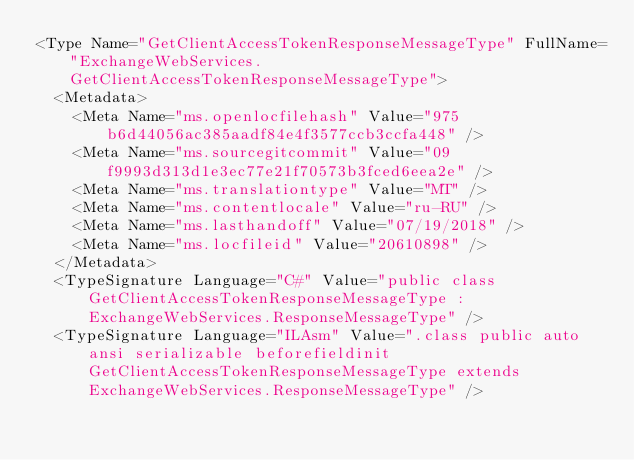<code> <loc_0><loc_0><loc_500><loc_500><_XML_><Type Name="GetClientAccessTokenResponseMessageType" FullName="ExchangeWebServices.GetClientAccessTokenResponseMessageType">
  <Metadata>
    <Meta Name="ms.openlocfilehash" Value="975b6d44056ac385aadf84e4f3577ccb3ccfa448" />
    <Meta Name="ms.sourcegitcommit" Value="09f9993d313d1e3ec77e21f70573b3fced6eea2e" />
    <Meta Name="ms.translationtype" Value="MT" />
    <Meta Name="ms.contentlocale" Value="ru-RU" />
    <Meta Name="ms.lasthandoff" Value="07/19/2018" />
    <Meta Name="ms.locfileid" Value="20610898" />
  </Metadata>
  <TypeSignature Language="C#" Value="public class GetClientAccessTokenResponseMessageType : ExchangeWebServices.ResponseMessageType" />
  <TypeSignature Language="ILAsm" Value=".class public auto ansi serializable beforefieldinit GetClientAccessTokenResponseMessageType extends ExchangeWebServices.ResponseMessageType" /></code> 